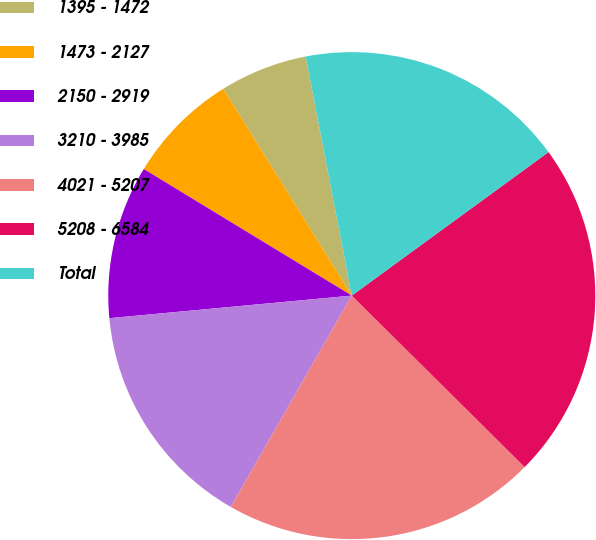Convert chart. <chart><loc_0><loc_0><loc_500><loc_500><pie_chart><fcel>1395 - 1472<fcel>1473 - 2127<fcel>2150 - 2919<fcel>3210 - 3985<fcel>4021 - 5207<fcel>5208 - 6584<fcel>Total<nl><fcel>5.82%<fcel>7.45%<fcel>10.18%<fcel>15.25%<fcel>20.84%<fcel>22.47%<fcel>18.0%<nl></chart> 